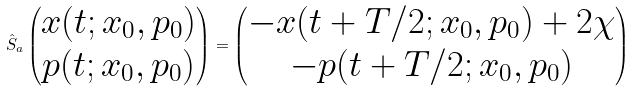Convert formula to latex. <formula><loc_0><loc_0><loc_500><loc_500>\hat { S } _ { a } \begin{pmatrix} x ( t ; x _ { 0 } , p _ { 0 } ) \\ p ( t ; x _ { 0 } , p _ { 0 } ) \end{pmatrix} = \begin{pmatrix} - x ( t + T / 2 ; x _ { 0 } , p _ { 0 } ) + 2 \chi \\ - p ( t + T / 2 ; x _ { 0 } , p _ { 0 } ) \end{pmatrix}</formula> 